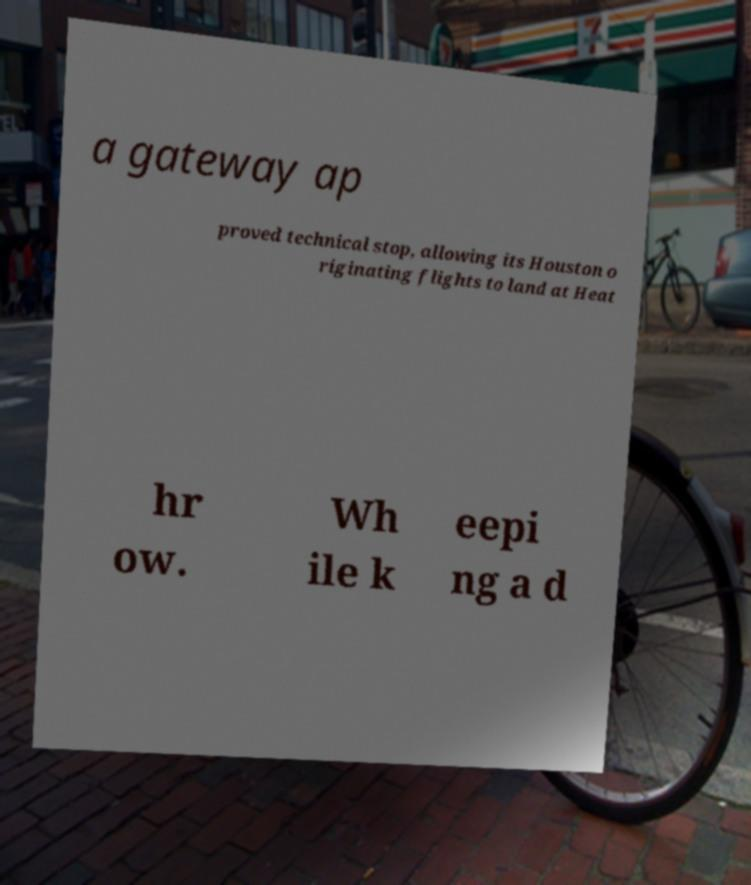Please identify and transcribe the text found in this image. a gateway ap proved technical stop, allowing its Houston o riginating flights to land at Heat hr ow. Wh ile k eepi ng a d 